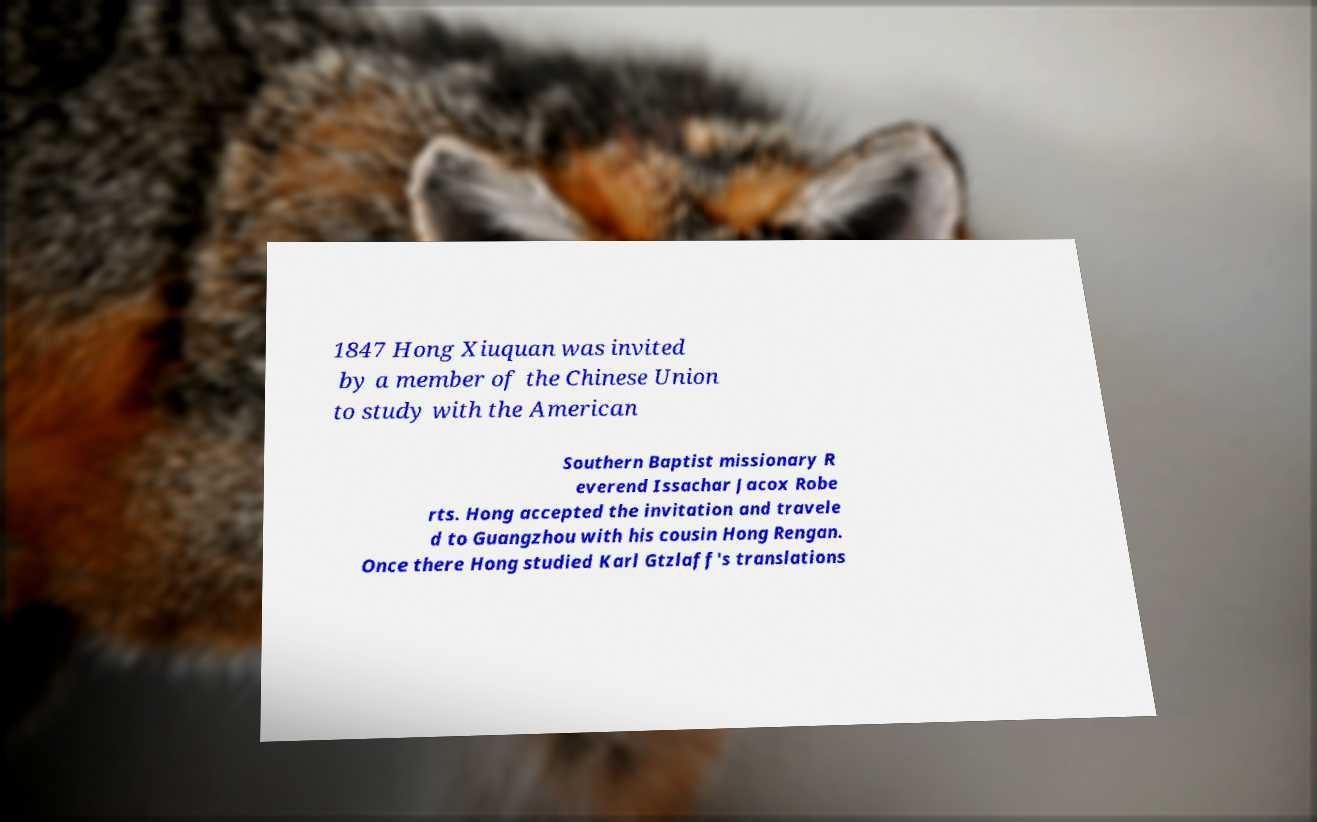Could you assist in decoding the text presented in this image and type it out clearly? 1847 Hong Xiuquan was invited by a member of the Chinese Union to study with the American Southern Baptist missionary R everend Issachar Jacox Robe rts. Hong accepted the invitation and travele d to Guangzhou with his cousin Hong Rengan. Once there Hong studied Karl Gtzlaff's translations 